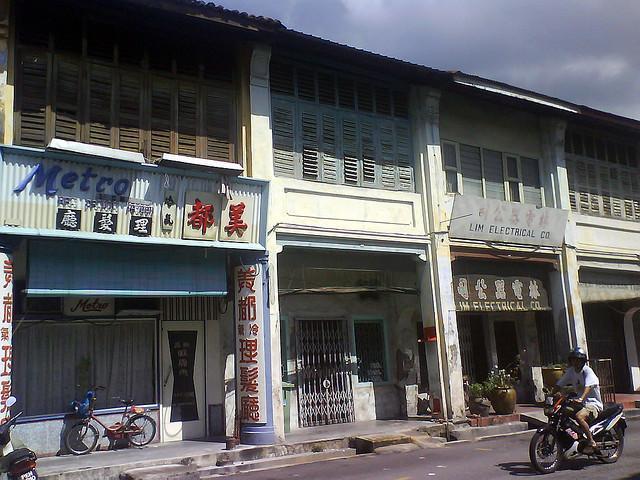How many people is there?
Give a very brief answer. 1. How many bicycles are in the image?
Give a very brief answer. 1. How many brown cows are there on the beach?
Give a very brief answer. 0. 